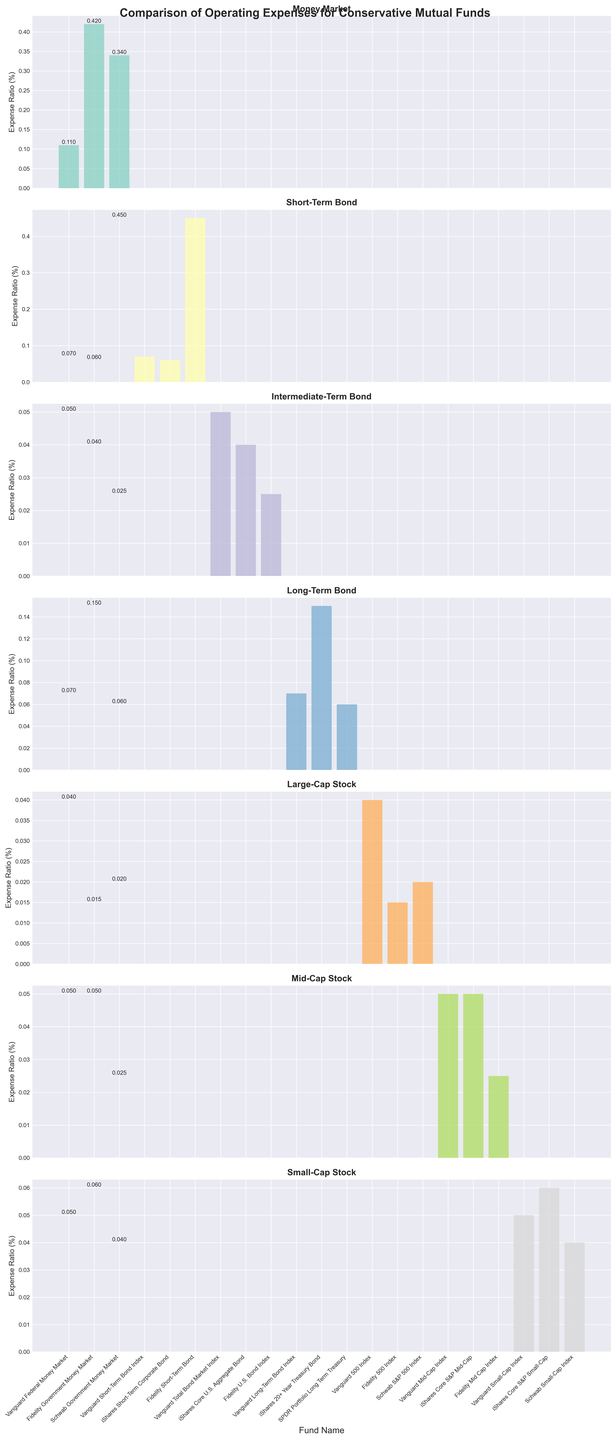Which fund in the Money Market asset class has the lowest expense ratio? Look at the bars for each fund in the Money Market asset class. The bar representing the Vanguard Federal Money Market is the shortest.
Answer: Vanguard Federal Money Market What is the difference in expense ratio between the Fidelity Short-Term Bond and the iShares Short-Term Corporate Bond? Identify the expense ratios for Fidelity Short-Term Bond and iShares Short-Term Corporate Bond. Subtract 0.06 from 0.45 to get the difference.
Answer: 0.39 Which asset class has the fund with the lowest expense ratio across all classes? Look across all subplots to find the shortest bar, which is the Fidelity 500 Index in the Large-Cap Stock asset class.
Answer: Large-Cap Stock What is the average expense ratio of the funds in the Long-Term Bond asset class? The expense ratios are 0.07, 0.15, and 0.06. Calculate the average: (0.07 + 0.15 + 0.06) / 3 = 0.0933.
Answer: 0.0933 How does the highest expense ratio in the Small-Cap Stock asset class compare to the highest in the Money Market asset class? The highest expense ratio in Small-Cap Stock is 0.06 (iShares Core S&P Small-Cap), and in Money Market, it is 0.42 (Fidelity Government Money Market). Compare 0.06 to 0.42.
Answer: Small-Cap Stock is lower Which fund has the highest expense ratio in the Short-Term Bond asset class, and what is its value? Find the tallest bar in the Short-Term Bond asset class subplot, which is the Fidelity Short-Term Bond.
Answer: Fidelity Short-Term Bond, 0.45 What is the range of expense ratios in the Intermediate-Term Bond asset class? The expense ratios are 0.05, 0.04, and 0.025. Calculate the range: 0.05 - 0.025 = 0.025.
Answer: 0.025 Compare the expense ratios of Vanguard Small-Cap Index and Schwab Small-Cap Index and mention which one is higher. Locate Vanguard Small-Cap Index (0.05) and Schwab Small-Cap Index (0.04); compare 0.05 with 0.04.
Answer: Vanguard Small-Cap Index is higher 